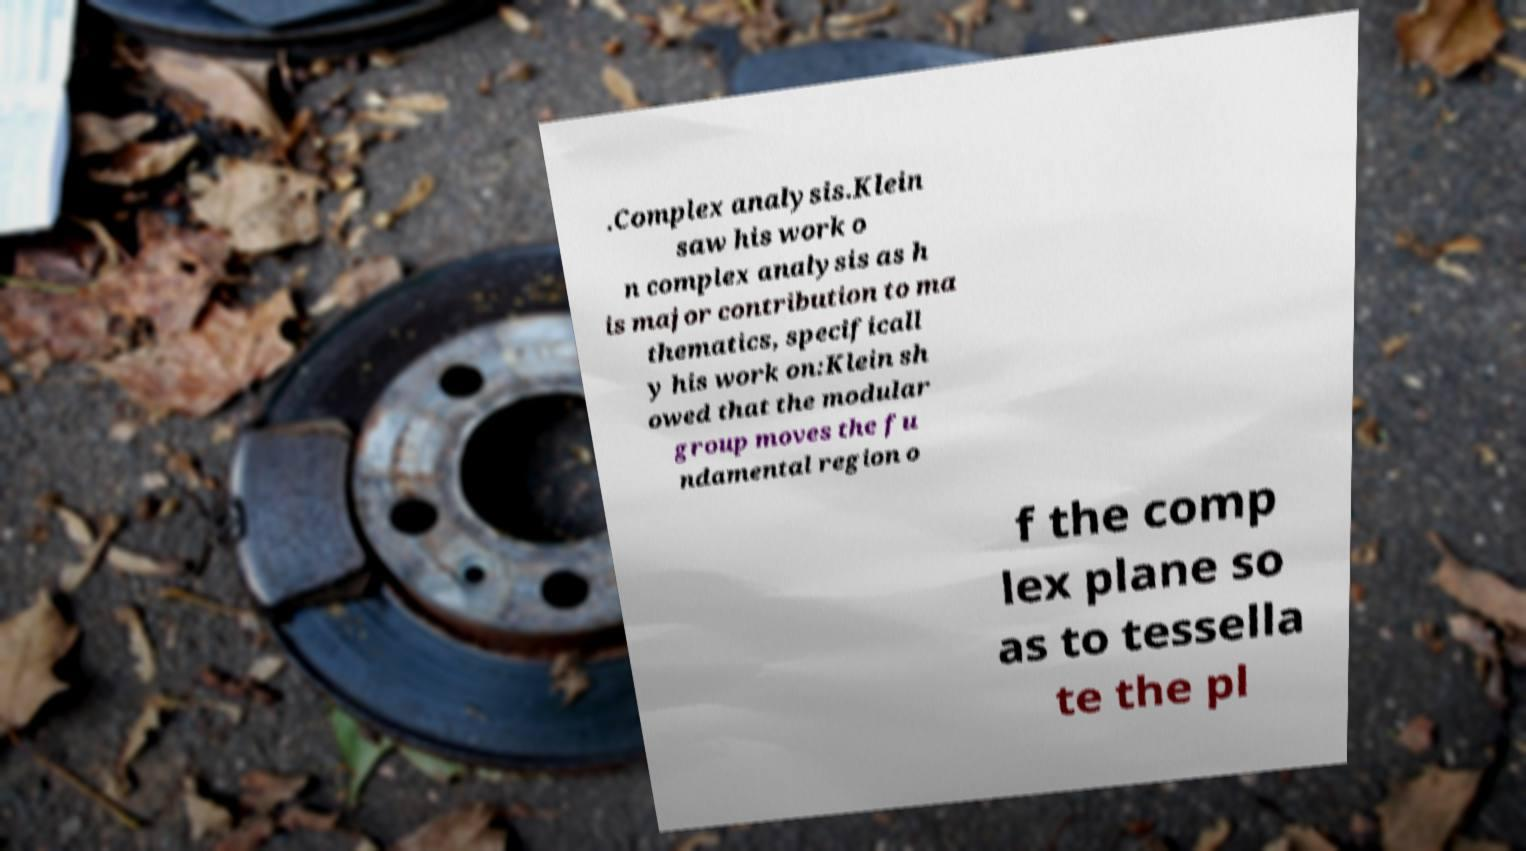For documentation purposes, I need the text within this image transcribed. Could you provide that? .Complex analysis.Klein saw his work o n complex analysis as h is major contribution to ma thematics, specificall y his work on:Klein sh owed that the modular group moves the fu ndamental region o f the comp lex plane so as to tessella te the pl 